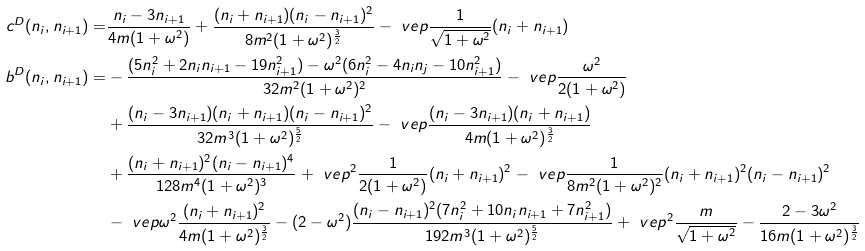Convert formula to latex. <formula><loc_0><loc_0><loc_500><loc_500>c ^ { D } ( n _ { i } , n _ { i + 1 } ) = & \frac { n _ { i } - 3 n _ { i + 1 } } { 4 m ( 1 + \omega ^ { 2 } ) } + \frac { ( n _ { i } + n _ { i + 1 } ) ( n _ { i } - n _ { i + 1 } ) ^ { 2 } } { 8 m ^ { 2 } ( 1 + \omega ^ { 2 } ) ^ { \frac { 3 } { 2 } } } - \ v e p \frac { 1 } { \sqrt { 1 + \omega ^ { 2 } } } ( n _ { i } + n _ { i + 1 } ) \\ b ^ { D } ( n _ { i } , n _ { i + 1 } ) = & - \frac { ( 5 n _ { i } ^ { 2 } + 2 n _ { i } n _ { i + 1 } - 1 9 n _ { i + 1 } ^ { 2 } ) - \omega ^ { 2 } ( 6 n _ { i } ^ { 2 } - 4 n _ { i } n _ { j } - 1 0 n _ { i + 1 } ^ { 2 } ) } { 3 2 m ^ { 2 } ( 1 + \omega ^ { 2 } ) ^ { 2 } } - \ v e p \frac { \omega ^ { 2 } } { 2 ( 1 + \omega ^ { 2 } ) } \\ & + \frac { ( n _ { i } - 3 n _ { i + 1 } ) ( n _ { i } + n _ { i + 1 } ) ( n _ { i } - n _ { i + 1 } ) ^ { 2 } } { 3 2 m ^ { 3 } ( 1 + \omega ^ { 2 } ) ^ { \frac { 5 } { 2 } } } - \ v e p \frac { ( n _ { i } - 3 n _ { i + 1 } ) ( n _ { i } + n _ { i + 1 } ) } { 4 m ( 1 + \omega ^ { 2 } ) ^ { \frac { 3 } { 2 } } } \\ & + \frac { ( n _ { i } + n _ { i + 1 } ) ^ { 2 } ( n _ { i } - n _ { i + 1 } ) ^ { 4 } } { 1 2 8 m ^ { 4 } ( 1 + \omega ^ { 2 } ) ^ { 3 } } + \ v e p ^ { 2 } \frac { 1 } { 2 ( 1 + \omega ^ { 2 } ) } ( n _ { i } + n _ { i + 1 } ) ^ { 2 } - \ v e p \frac { 1 } { 8 m ^ { 2 } ( 1 + \omega ^ { 2 } ) ^ { 2 } } ( n _ { i } + n _ { i + 1 } ) ^ { 2 } ( n _ { i } - n _ { i + 1 } ) ^ { 2 } \\ & - \ v e p \omega ^ { 2 } \frac { ( n _ { i } + n _ { i + 1 } ) ^ { 2 } } { 4 m ( 1 + \omega ^ { 2 } ) ^ { \frac { 3 } { 2 } } } - ( 2 - \omega ^ { 2 } ) \frac { ( n _ { i } - n _ { i + 1 } ) ^ { 2 } ( 7 n _ { i } ^ { 2 } + 1 0 n _ { i } n _ { i + 1 } + 7 n _ { i + 1 } ^ { 2 } ) } { 1 9 2 m ^ { 3 } ( 1 + \omega ^ { 2 } ) ^ { \frac { 5 } { 2 } } } + \ v e p ^ { 2 } \frac { m } { \sqrt { 1 + \omega ^ { 2 } } } - \frac { 2 - 3 \omega ^ { 2 } } { 1 6 m ( 1 + \omega ^ { 2 } ) ^ { \frac { 3 } { 2 } } }</formula> 